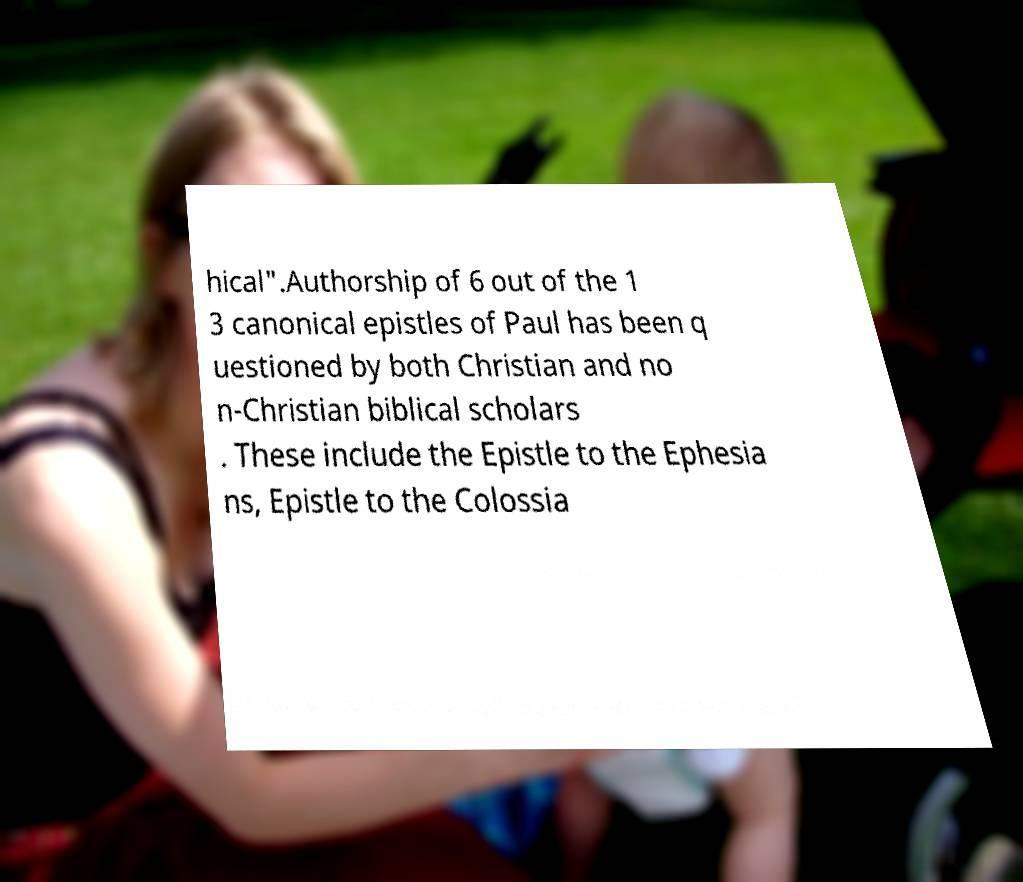Please read and relay the text visible in this image. What does it say? hical".Authorship of 6 out of the 1 3 canonical epistles of Paul has been q uestioned by both Christian and no n-Christian biblical scholars . These include the Epistle to the Ephesia ns, Epistle to the Colossia 